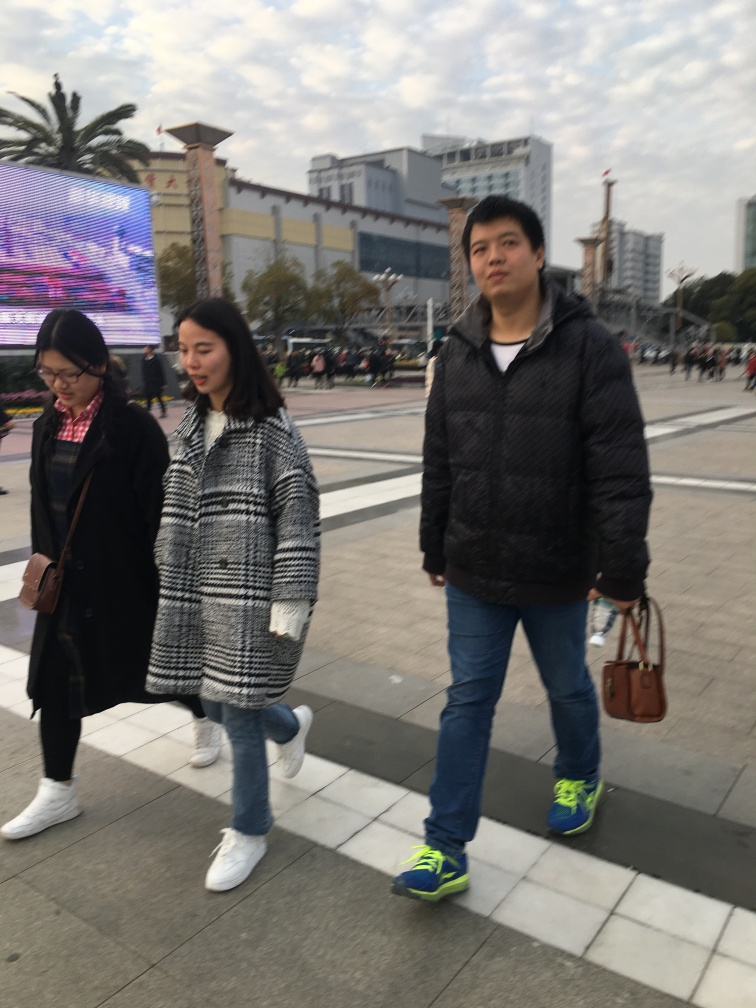Describe the focus of the photo.
A. The focus is partially clear, partially blurry.
B. The focus is very clear.
C. The focus is completely out of focus.
Answer with the option's letter from the given choices directly.
 B. 